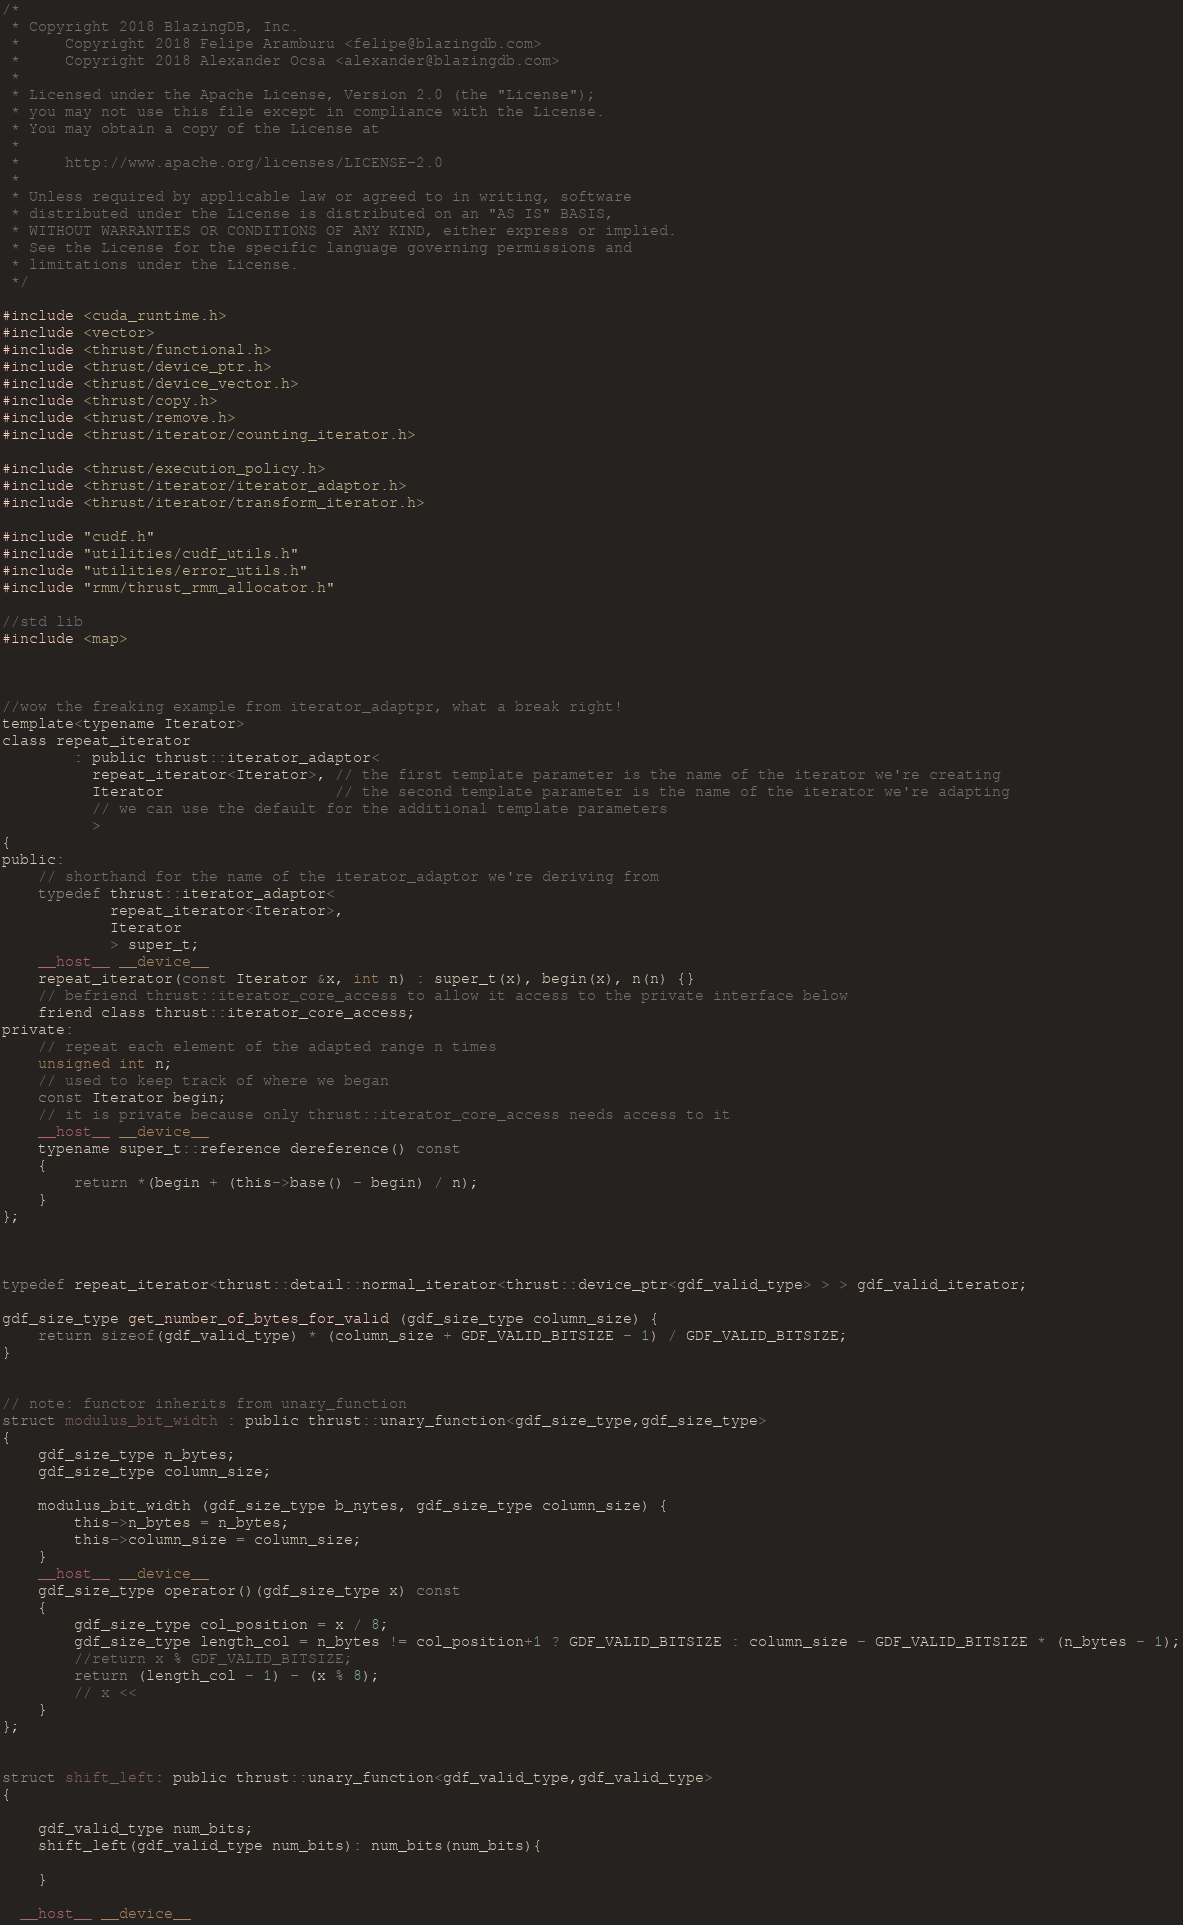<code> <loc_0><loc_0><loc_500><loc_500><_Cuda_>/*
 * Copyright 2018 BlazingDB, Inc.
 *     Copyright 2018 Felipe Aramburu <felipe@blazingdb.com>
 *     Copyright 2018 Alexander Ocsa <alexander@blazingdb.com>
 *
 * Licensed under the Apache License, Version 2.0 (the "License");
 * you may not use this file except in compliance with the License.
 * You may obtain a copy of the License at
 *
 *     http://www.apache.org/licenses/LICENSE-2.0
 *
 * Unless required by applicable law or agreed to in writing, software
 * distributed under the License is distributed on an "AS IS" BASIS,
 * WITHOUT WARRANTIES OR CONDITIONS OF ANY KIND, either express or implied.
 * See the License for the specific language governing permissions and
 * limitations under the License.
 */

#include <cuda_runtime.h>
#include <vector>
#include <thrust/functional.h>
#include <thrust/device_ptr.h>
#include <thrust/device_vector.h>
#include <thrust/copy.h>
#include <thrust/remove.h>
#include <thrust/iterator/counting_iterator.h>

#include <thrust/execution_policy.h>
#include <thrust/iterator/iterator_adaptor.h>
#include <thrust/iterator/transform_iterator.h>

#include "cudf.h"
#include "utilities/cudf_utils.h"
#include "utilities/error_utils.h"
#include "rmm/thrust_rmm_allocator.h"

//std lib
#include <map>



//wow the freaking example from iterator_adaptpr, what a break right!
template<typename Iterator>
class repeat_iterator
		: public thrust::iterator_adaptor<
		  repeat_iterator<Iterator>, // the first template parameter is the name of the iterator we're creating
		  Iterator                   // the second template parameter is the name of the iterator we're adapting
		  // we can use the default for the additional template parameters
		  >
{
public:
	// shorthand for the name of the iterator_adaptor we're deriving from
	typedef thrust::iterator_adaptor<
			repeat_iterator<Iterator>,
			Iterator
			> super_t;
	__host__ __device__
	repeat_iterator(const Iterator &x, int n) : super_t(x), begin(x), n(n) {}
	// befriend thrust::iterator_core_access to allow it access to the private interface below
	friend class thrust::iterator_core_access;
private:
	// repeat each element of the adapted range n times
	unsigned int n;
	// used to keep track of where we began
	const Iterator begin;
	// it is private because only thrust::iterator_core_access needs access to it
	__host__ __device__
	typename super_t::reference dereference() const
	{
		return *(begin + (this->base() - begin) / n);
	}
};



typedef repeat_iterator<thrust::detail::normal_iterator<thrust::device_ptr<gdf_valid_type> > > gdf_valid_iterator;

gdf_size_type get_number_of_bytes_for_valid (gdf_size_type column_size) {
    return sizeof(gdf_valid_type) * (column_size + GDF_VALID_BITSIZE - 1) / GDF_VALID_BITSIZE;
}


// note: functor inherits from unary_function
struct modulus_bit_width : public thrust::unary_function<gdf_size_type,gdf_size_type>
{
	gdf_size_type n_bytes;
	gdf_size_type column_size;
	
	modulus_bit_width (gdf_size_type b_nytes, gdf_size_type column_size) {
		this->n_bytes = n_bytes;
		this->column_size = column_size;
	}
	__host__ __device__
	gdf_size_type operator()(gdf_size_type x) const
	{
		gdf_size_type col_position = x / 8;	
        gdf_size_type length_col = n_bytes != col_position+1 ? GDF_VALID_BITSIZE : column_size - GDF_VALID_BITSIZE * (n_bytes - 1);
		//return x % GDF_VALID_BITSIZE;
		return (length_col - 1) - (x % 8);
		// x << 
	}
};


struct shift_left: public thrust::unary_function<gdf_valid_type,gdf_valid_type>
{

	gdf_valid_type num_bits;
	shift_left(gdf_valid_type num_bits): num_bits(num_bits){

	}

  __host__ __device__</code> 